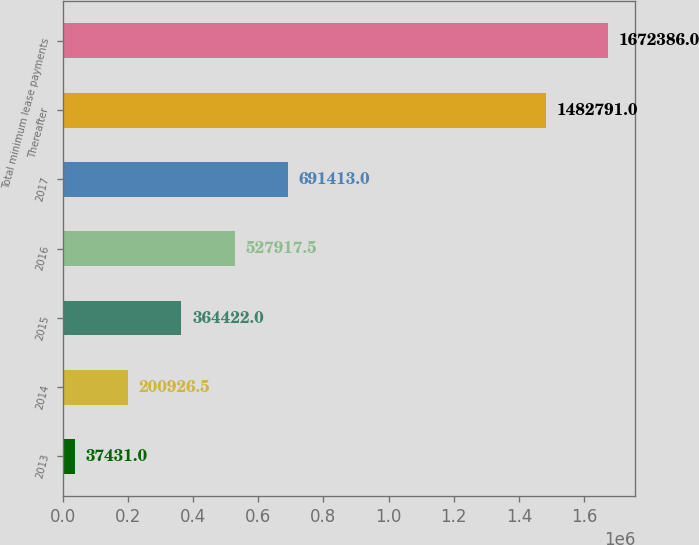Convert chart. <chart><loc_0><loc_0><loc_500><loc_500><bar_chart><fcel>2013<fcel>2014<fcel>2015<fcel>2016<fcel>2017<fcel>Thereafter<fcel>Total minimum lease payments<nl><fcel>37431<fcel>200926<fcel>364422<fcel>527918<fcel>691413<fcel>1.48279e+06<fcel>1.67239e+06<nl></chart> 